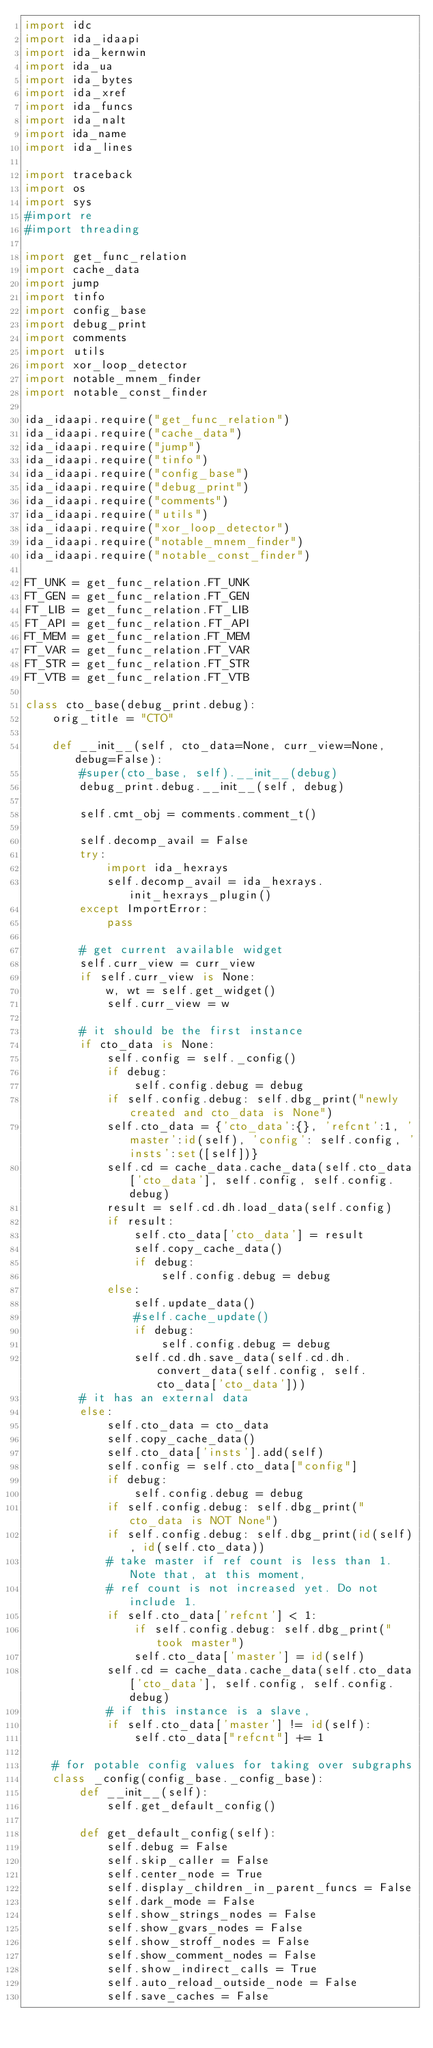Convert code to text. <code><loc_0><loc_0><loc_500><loc_500><_Python_>import idc
import ida_idaapi
import ida_kernwin
import ida_ua
import ida_bytes
import ida_xref
import ida_funcs
import ida_nalt
import ida_name
import ida_lines

import traceback
import os
import sys
#import re
#import threading

import get_func_relation
import cache_data
import jump
import tinfo
import config_base
import debug_print
import comments
import utils
import xor_loop_detector
import notable_mnem_finder
import notable_const_finder

ida_idaapi.require("get_func_relation")
ida_idaapi.require("cache_data")
ida_idaapi.require("jump")
ida_idaapi.require("tinfo")
ida_idaapi.require("config_base")
ida_idaapi.require("debug_print")
ida_idaapi.require("comments")
ida_idaapi.require("utils")
ida_idaapi.require("xor_loop_detector")
ida_idaapi.require("notable_mnem_finder")
ida_idaapi.require("notable_const_finder")

FT_UNK = get_func_relation.FT_UNK
FT_GEN = get_func_relation.FT_GEN
FT_LIB = get_func_relation.FT_LIB
FT_API = get_func_relation.FT_API
FT_MEM = get_func_relation.FT_MEM
FT_VAR = get_func_relation.FT_VAR
FT_STR = get_func_relation.FT_STR
FT_VTB = get_func_relation.FT_VTB

class cto_base(debug_print.debug):
    orig_title = "CTO"
    
    def __init__(self, cto_data=None, curr_view=None, debug=False):
        #super(cto_base, self).__init__(debug)
        debug_print.debug.__init__(self, debug)
        
        self.cmt_obj = comments.comment_t()

        self.decomp_avail = False
        try:
            import ida_hexrays
            self.decomp_avail = ida_hexrays.init_hexrays_plugin()
        except ImportError:
            pass
        
        # get current available widget
        self.curr_view = curr_view
        if self.curr_view is None:
            w, wt = self.get_widget()
            self.curr_view = w
        
        # it should be the first instance
        if cto_data is None:
            self.config = self._config()
            if debug:
                self.config.debug = debug
            if self.config.debug: self.dbg_print("newly created and cto_data is None")
            self.cto_data = {'cto_data':{}, 'refcnt':1, 'master':id(self), 'config': self.config, 'insts':set([self])}
            self.cd = cache_data.cache_data(self.cto_data['cto_data'], self.config, self.config.debug)
            result = self.cd.dh.load_data(self.config)
            if result:
                self.cto_data['cto_data'] = result
                self.copy_cache_data()
                if debug:
                    self.config.debug = debug
            else:
                self.update_data()
                #self.cache_update()
                if debug:
                    self.config.debug = debug
                self.cd.dh.save_data(self.cd.dh.convert_data(self.config, self.cto_data['cto_data']))
        # it has an external data
        else:
            self.cto_data = cto_data
            self.copy_cache_data()
            self.cto_data['insts'].add(self)
            self.config = self.cto_data["config"]
            if debug:
                self.config.debug = debug
            if self.config.debug: self.dbg_print("cto_data is NOT None")
            if self.config.debug: self.dbg_print(id(self), id(self.cto_data))
            # take master if ref count is less than 1. Note that, at this moment,
            # ref count is not increased yet. Do not include 1.
            if self.cto_data['refcnt'] < 1:
                if self.config.debug: self.dbg_print("took master")
                self.cto_data['master'] = id(self)
            self.cd = cache_data.cache_data(self.cto_data['cto_data'], self.config, self.config.debug)
            # if this instance is a slave, 
            if self.cto_data['master'] != id(self):
                self.cto_data["refcnt"] += 1
        
    # for potable config values for taking over subgraphs
    class _config(config_base._config_base):
        def __init__(self):
            self.get_default_config()
        
        def get_default_config(self):
            self.debug = False
            self.skip_caller = False
            self.center_node = True
            self.display_children_in_parent_funcs = False
            self.dark_mode = False
            self.show_strings_nodes = False
            self.show_gvars_nodes = False
            self.show_stroff_nodes = False
            self.show_comment_nodes = False
            self.show_indirect_calls = True
            self.auto_reload_outside_node = False
            self.save_caches = False
    </code> 